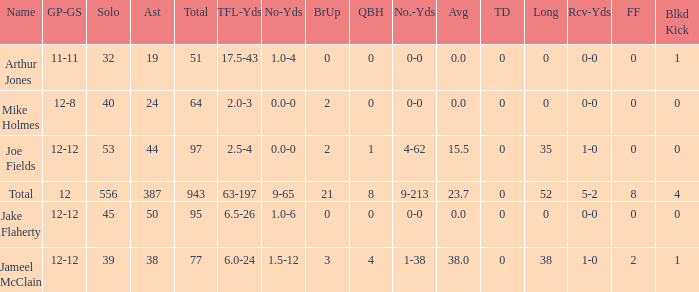What is the largest number of tds scored for a player? 0.0. 